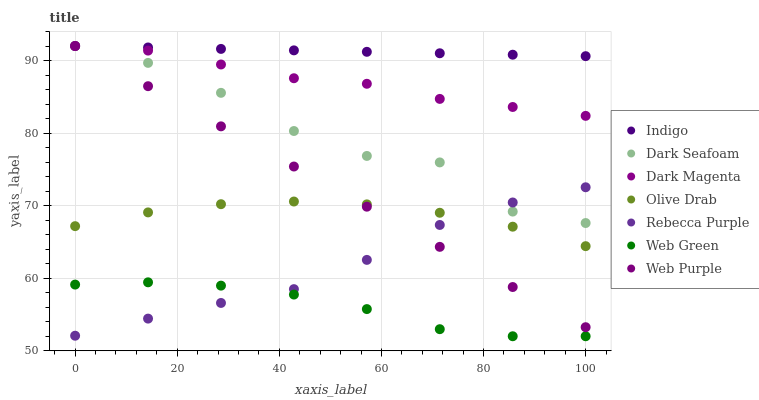Does Web Green have the minimum area under the curve?
Answer yes or no. Yes. Does Indigo have the maximum area under the curve?
Answer yes or no. Yes. Does Dark Magenta have the minimum area under the curve?
Answer yes or no. No. Does Dark Magenta have the maximum area under the curve?
Answer yes or no. No. Is Indigo the smoothest?
Answer yes or no. Yes. Is Dark Seafoam the roughest?
Answer yes or no. Yes. Is Dark Magenta the smoothest?
Answer yes or no. No. Is Dark Magenta the roughest?
Answer yes or no. No. Does Web Green have the lowest value?
Answer yes or no. Yes. Does Dark Magenta have the lowest value?
Answer yes or no. No. Does Dark Seafoam have the highest value?
Answer yes or no. Yes. Does Web Green have the highest value?
Answer yes or no. No. Is Web Green less than Dark Seafoam?
Answer yes or no. Yes. Is Dark Magenta greater than Web Green?
Answer yes or no. Yes. Does Web Purple intersect Dark Seafoam?
Answer yes or no. Yes. Is Web Purple less than Dark Seafoam?
Answer yes or no. No. Is Web Purple greater than Dark Seafoam?
Answer yes or no. No. Does Web Green intersect Dark Seafoam?
Answer yes or no. No. 